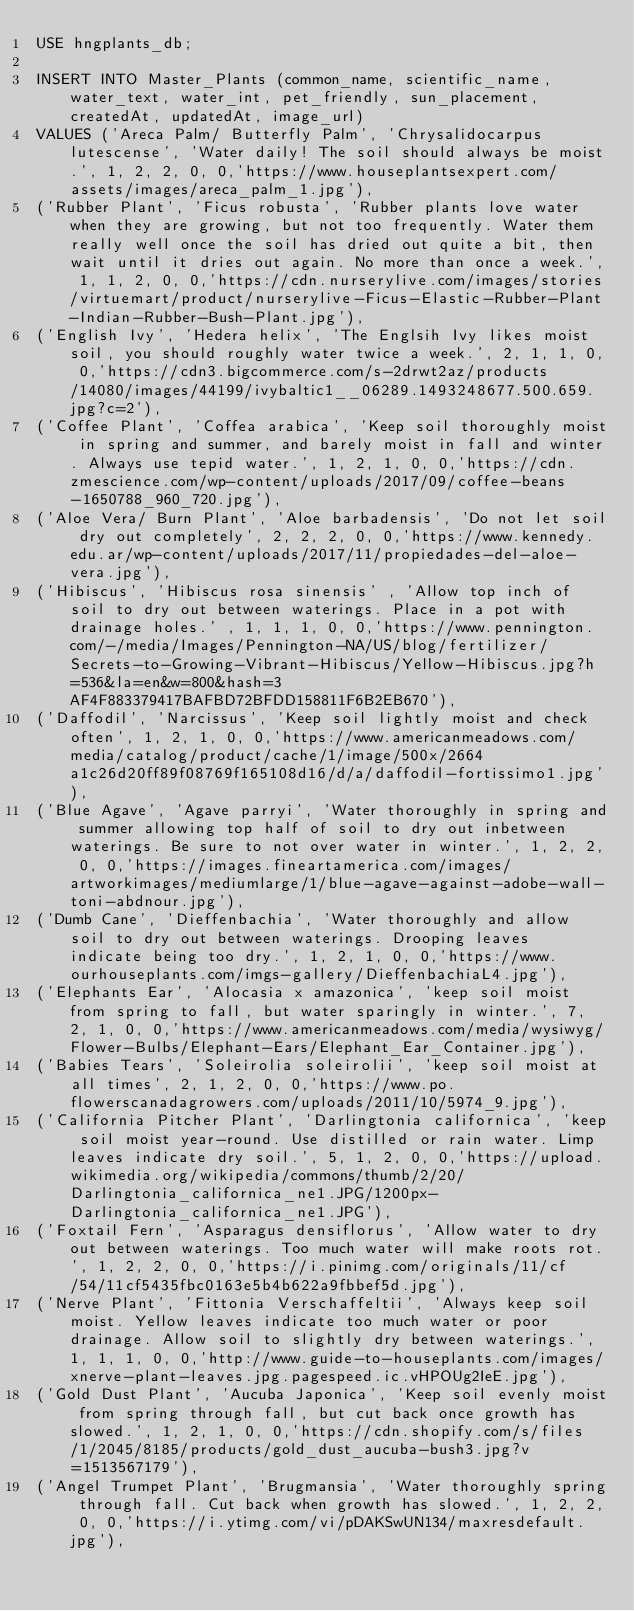Convert code to text. <code><loc_0><loc_0><loc_500><loc_500><_SQL_>USE hngplants_db;

INSERT INTO Master_Plants (common_name, scientific_name, water_text, water_int, pet_friendly, sun_placement, createdAt, updatedAt, image_url) 
VALUES ('Areca Palm/ Butterfly Palm', 'Chrysalidocarpus lutescense', 'Water daily! The soil should always be moist.', 1, 2, 2, 0, 0,'https://www.houseplantsexpert.com/assets/images/areca_palm_1.jpg'),
('Rubber Plant', 'Ficus robusta', 'Rubber plants love water when they are growing, but not too frequently. Water them really well once the soil has dried out quite a bit, then wait until it dries out again. No more than once a week.', 1, 1, 2, 0, 0,'https://cdn.nurserylive.com/images/stories/virtuemart/product/nurserylive-Ficus-Elastic-Rubber-Plant-Indian-Rubber-Bush-Plant.jpg'),
('English Ivy', 'Hedera helix', 'The Englsih Ivy likes moist soil, you should roughly water twice a week.', 2, 1, 1, 0, 0,'https://cdn3.bigcommerce.com/s-2drwt2az/products/14080/images/44199/ivybaltic1__06289.1493248677.500.659.jpg?c=2'),
('Coffee Plant', 'Coffea arabica', 'Keep soil thoroughly moist in spring and summer, and barely moist in fall and winter. Always use tepid water.', 1, 2, 1, 0, 0,'https://cdn.zmescience.com/wp-content/uploads/2017/09/coffee-beans-1650788_960_720.jpg'),
('Aloe Vera/ Burn Plant', 'Aloe barbadensis', 'Do not let soil dry out completely', 2, 2, 2, 0, 0,'https://www.kennedy.edu.ar/wp-content/uploads/2017/11/propiedades-del-aloe-vera.jpg'),
('Hibiscus', 'Hibiscus rosa sinensis' , 'Allow top inch of soil to dry out between waterings. Place in a pot with drainage holes.' , 1, 1, 1, 0, 0,'https://www.pennington.com/-/media/Images/Pennington-NA/US/blog/fertilizer/Secrets-to-Growing-Vibrant-Hibiscus/Yellow-Hibiscus.jpg?h=536&la=en&w=800&hash=3AF4F883379417BAFBD72BFDD158811F6B2EB670'),
('Daffodil', 'Narcissus', 'Keep soil lightly moist and check often', 1, 2, 1, 0, 0,'https://www.americanmeadows.com/media/catalog/product/cache/1/image/500x/2664a1c26d20ff89f08769f165108d16/d/a/daffodil-fortissimo1.jpg'),
('Blue Agave', 'Agave parryi', 'Water thoroughly in spring and summer allowing top half of soil to dry out inbetween waterings. Be sure to not over water in winter.', 1, 2, 2, 0, 0,'https://images.fineartamerica.com/images/artworkimages/mediumlarge/1/blue-agave-against-adobe-wall-toni-abdnour.jpg'),
('Dumb Cane', 'Dieffenbachia', 'Water thoroughly and allow soil to dry out between waterings. Drooping leaves indicate being too dry.', 1, 2, 1, 0, 0,'https://www.ourhouseplants.com/imgs-gallery/DieffenbachiaL4.jpg'),
('Elephants Ear', 'Alocasia x amazonica', 'keep soil moist from spring to fall, but water sparingly in winter.', 7, 2, 1, 0, 0,'https://www.americanmeadows.com/media/wysiwyg/Flower-Bulbs/Elephant-Ears/Elephant_Ear_Container.jpg'),
('Babies Tears', 'Soleirolia soleirolii', 'keep soil moist at all times', 2, 1, 2, 0, 0,'https://www.po.flowerscanadagrowers.com/uploads/2011/10/5974_9.jpg'),
('California Pitcher Plant', 'Darlingtonia californica', 'keep soil moist year-round. Use distilled or rain water. Limp leaves indicate dry soil.', 5, 1, 2, 0, 0,'https://upload.wikimedia.org/wikipedia/commons/thumb/2/20/Darlingtonia_californica_ne1.JPG/1200px-Darlingtonia_californica_ne1.JPG'),
('Foxtail Fern', 'Asparagus densiflorus', 'Allow water to dry out between waterings. Too much water will make roots rot.', 1, 2, 2, 0, 0,'https://i.pinimg.com/originals/11/cf/54/11cf5435fbc0163e5b4b622a9fbbef5d.jpg'),
('Nerve Plant', 'Fittonia Verschaffeltii', 'Always keep soil moist. Yellow leaves indicate too much water or poor drainage. Allow soil to slightly dry between waterings.', 1, 1, 1, 0, 0,'http://www.guide-to-houseplants.com/images/xnerve-plant-leaves.jpg.pagespeed.ic.vHPOUg2IeE.jpg'),
('Gold Dust Plant', 'Aucuba Japonica', 'Keep soil evenly moist from spring through fall, but cut back once growth has slowed.', 1, 2, 1, 0, 0,'https://cdn.shopify.com/s/files/1/2045/8185/products/gold_dust_aucuba-bush3.jpg?v=1513567179'),
('Angel Trumpet Plant', 'Brugmansia', 'Water thoroughly spring through fall. Cut back when growth has slowed.', 1, 2, 2, 0, 0,'https://i.ytimg.com/vi/pDAKSwUN134/maxresdefault.jpg'),</code> 